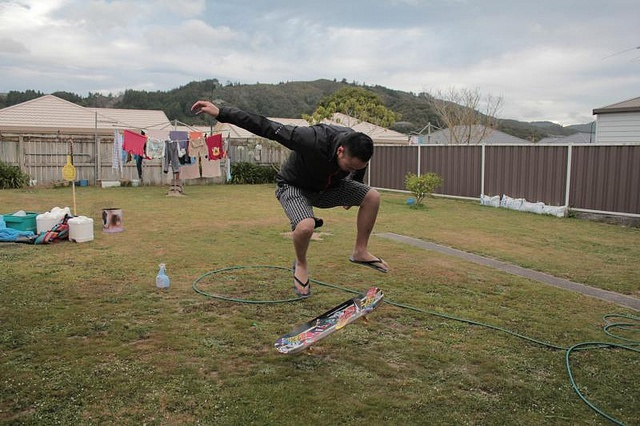Describe the objects in this image and their specific colors. I can see people in lightgray, black, gray, and maroon tones and skateboard in lightgray, gray, darkgray, and black tones in this image. 